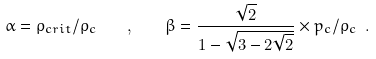<formula> <loc_0><loc_0><loc_500><loc_500>\alpha = \rho _ { c r i t } / \rho _ { c } \quad , \quad \beta = \frac { \sqrt { 2 } } { 1 - \sqrt { 3 - 2 \sqrt { 2 } } } \times p _ { c } / \rho _ { c } \ .</formula> 